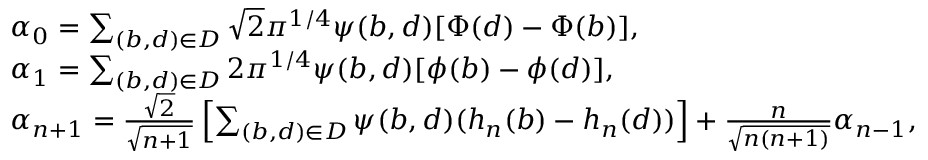<formula> <loc_0><loc_0><loc_500><loc_500>\begin{array} { r l } & { \alpha _ { 0 } = \sum _ { ( b , d ) \in D } \sqrt { 2 } \pi ^ { 1 / 4 } \psi ( b , d ) [ \Phi ( d ) - \Phi ( b ) ] , } \\ & { \alpha _ { 1 } = \sum _ { ( b , d ) \in D } 2 \pi ^ { 1 / 4 } \psi ( b , d ) [ \phi ( b ) - \phi ( d ) ] , } \\ & { \alpha _ { n + 1 } = \frac { \sqrt { 2 } } { \sqrt { n + 1 } } \left [ \sum _ { ( b , d ) \in D } \psi ( b , d ) ( h _ { n } ( b ) - h _ { n } ( d ) ) \right ] + \frac { n } { \sqrt { n ( n + 1 ) } } \alpha _ { n - 1 } , } \end{array}</formula> 